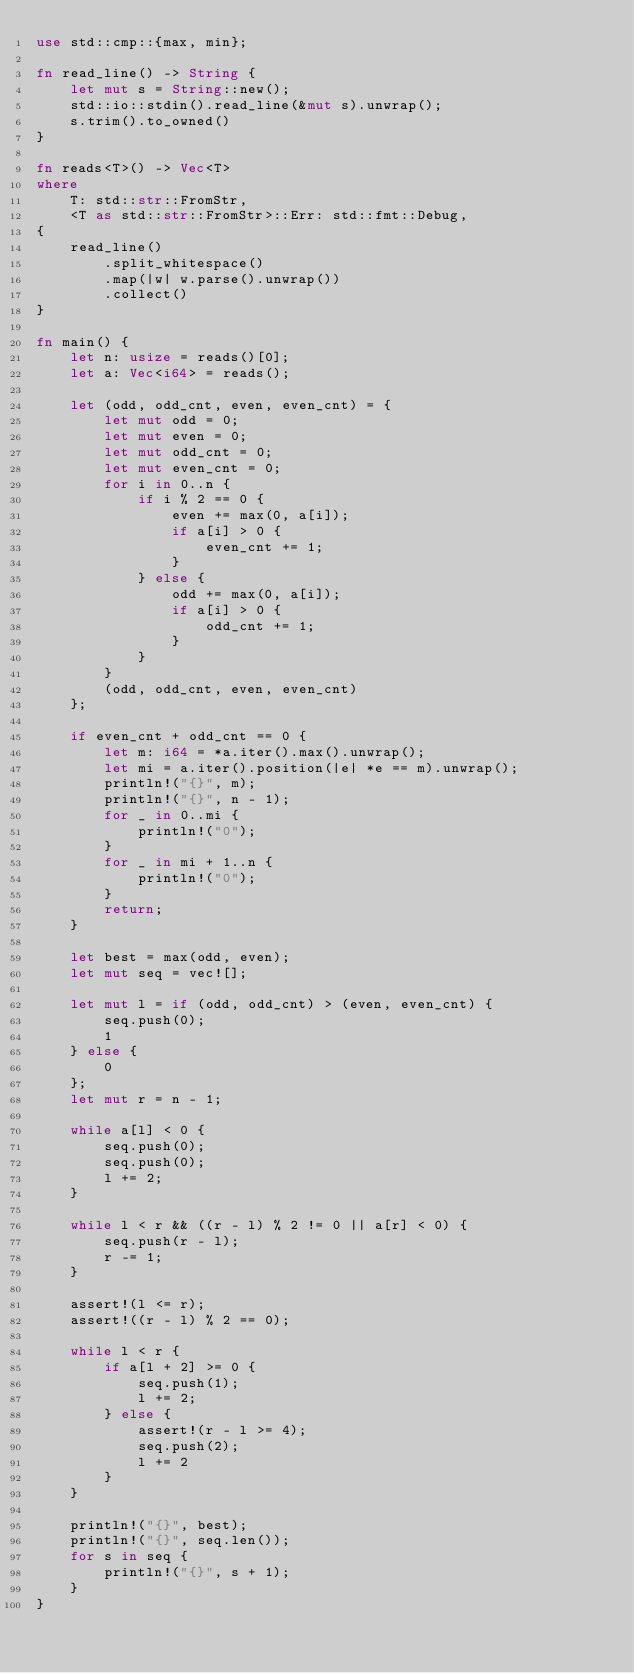Convert code to text. <code><loc_0><loc_0><loc_500><loc_500><_Rust_>use std::cmp::{max, min};

fn read_line() -> String {
    let mut s = String::new();
    std::io::stdin().read_line(&mut s).unwrap();
    s.trim().to_owned()
}

fn reads<T>() -> Vec<T>
where
    T: std::str::FromStr,
    <T as std::str::FromStr>::Err: std::fmt::Debug,
{
    read_line()
        .split_whitespace()
        .map(|w| w.parse().unwrap())
        .collect()
}

fn main() {
    let n: usize = reads()[0];
    let a: Vec<i64> = reads();

    let (odd, odd_cnt, even, even_cnt) = {
        let mut odd = 0;
        let mut even = 0;
        let mut odd_cnt = 0;
        let mut even_cnt = 0;
        for i in 0..n {
            if i % 2 == 0 {
                even += max(0, a[i]);
                if a[i] > 0 {
                    even_cnt += 1;
                }
            } else {
                odd += max(0, a[i]);
                if a[i] > 0 {
                    odd_cnt += 1;
                }
            }
        }
        (odd, odd_cnt, even, even_cnt)
    };

    if even_cnt + odd_cnt == 0 {
        let m: i64 = *a.iter().max().unwrap();
        let mi = a.iter().position(|e| *e == m).unwrap();
        println!("{}", m);
        println!("{}", n - 1);
        for _ in 0..mi {
            println!("0");
        }
        for _ in mi + 1..n {
            println!("0");
        }
        return;
    }

    let best = max(odd, even);
    let mut seq = vec![];

    let mut l = if (odd, odd_cnt) > (even, even_cnt) {
        seq.push(0);
        1
    } else {
        0
    };
    let mut r = n - 1;

    while a[l] < 0 {
        seq.push(0);
        seq.push(0);
        l += 2;
    }

    while l < r && ((r - l) % 2 != 0 || a[r] < 0) {
        seq.push(r - l);
        r -= 1;
    }

    assert!(l <= r);
    assert!((r - l) % 2 == 0);

    while l < r {
        if a[l + 2] >= 0 {
            seq.push(1);
            l += 2;
        } else {
            assert!(r - l >= 4);
            seq.push(2);
            l += 2
        }
    }

    println!("{}", best);
    println!("{}", seq.len());
    for s in seq {
        println!("{}", s + 1);
    }
}
</code> 